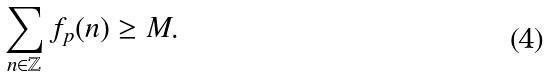<formula> <loc_0><loc_0><loc_500><loc_500>\sum _ { n \in \mathbb { Z } } f _ { p } ( n ) \geq M .</formula> 